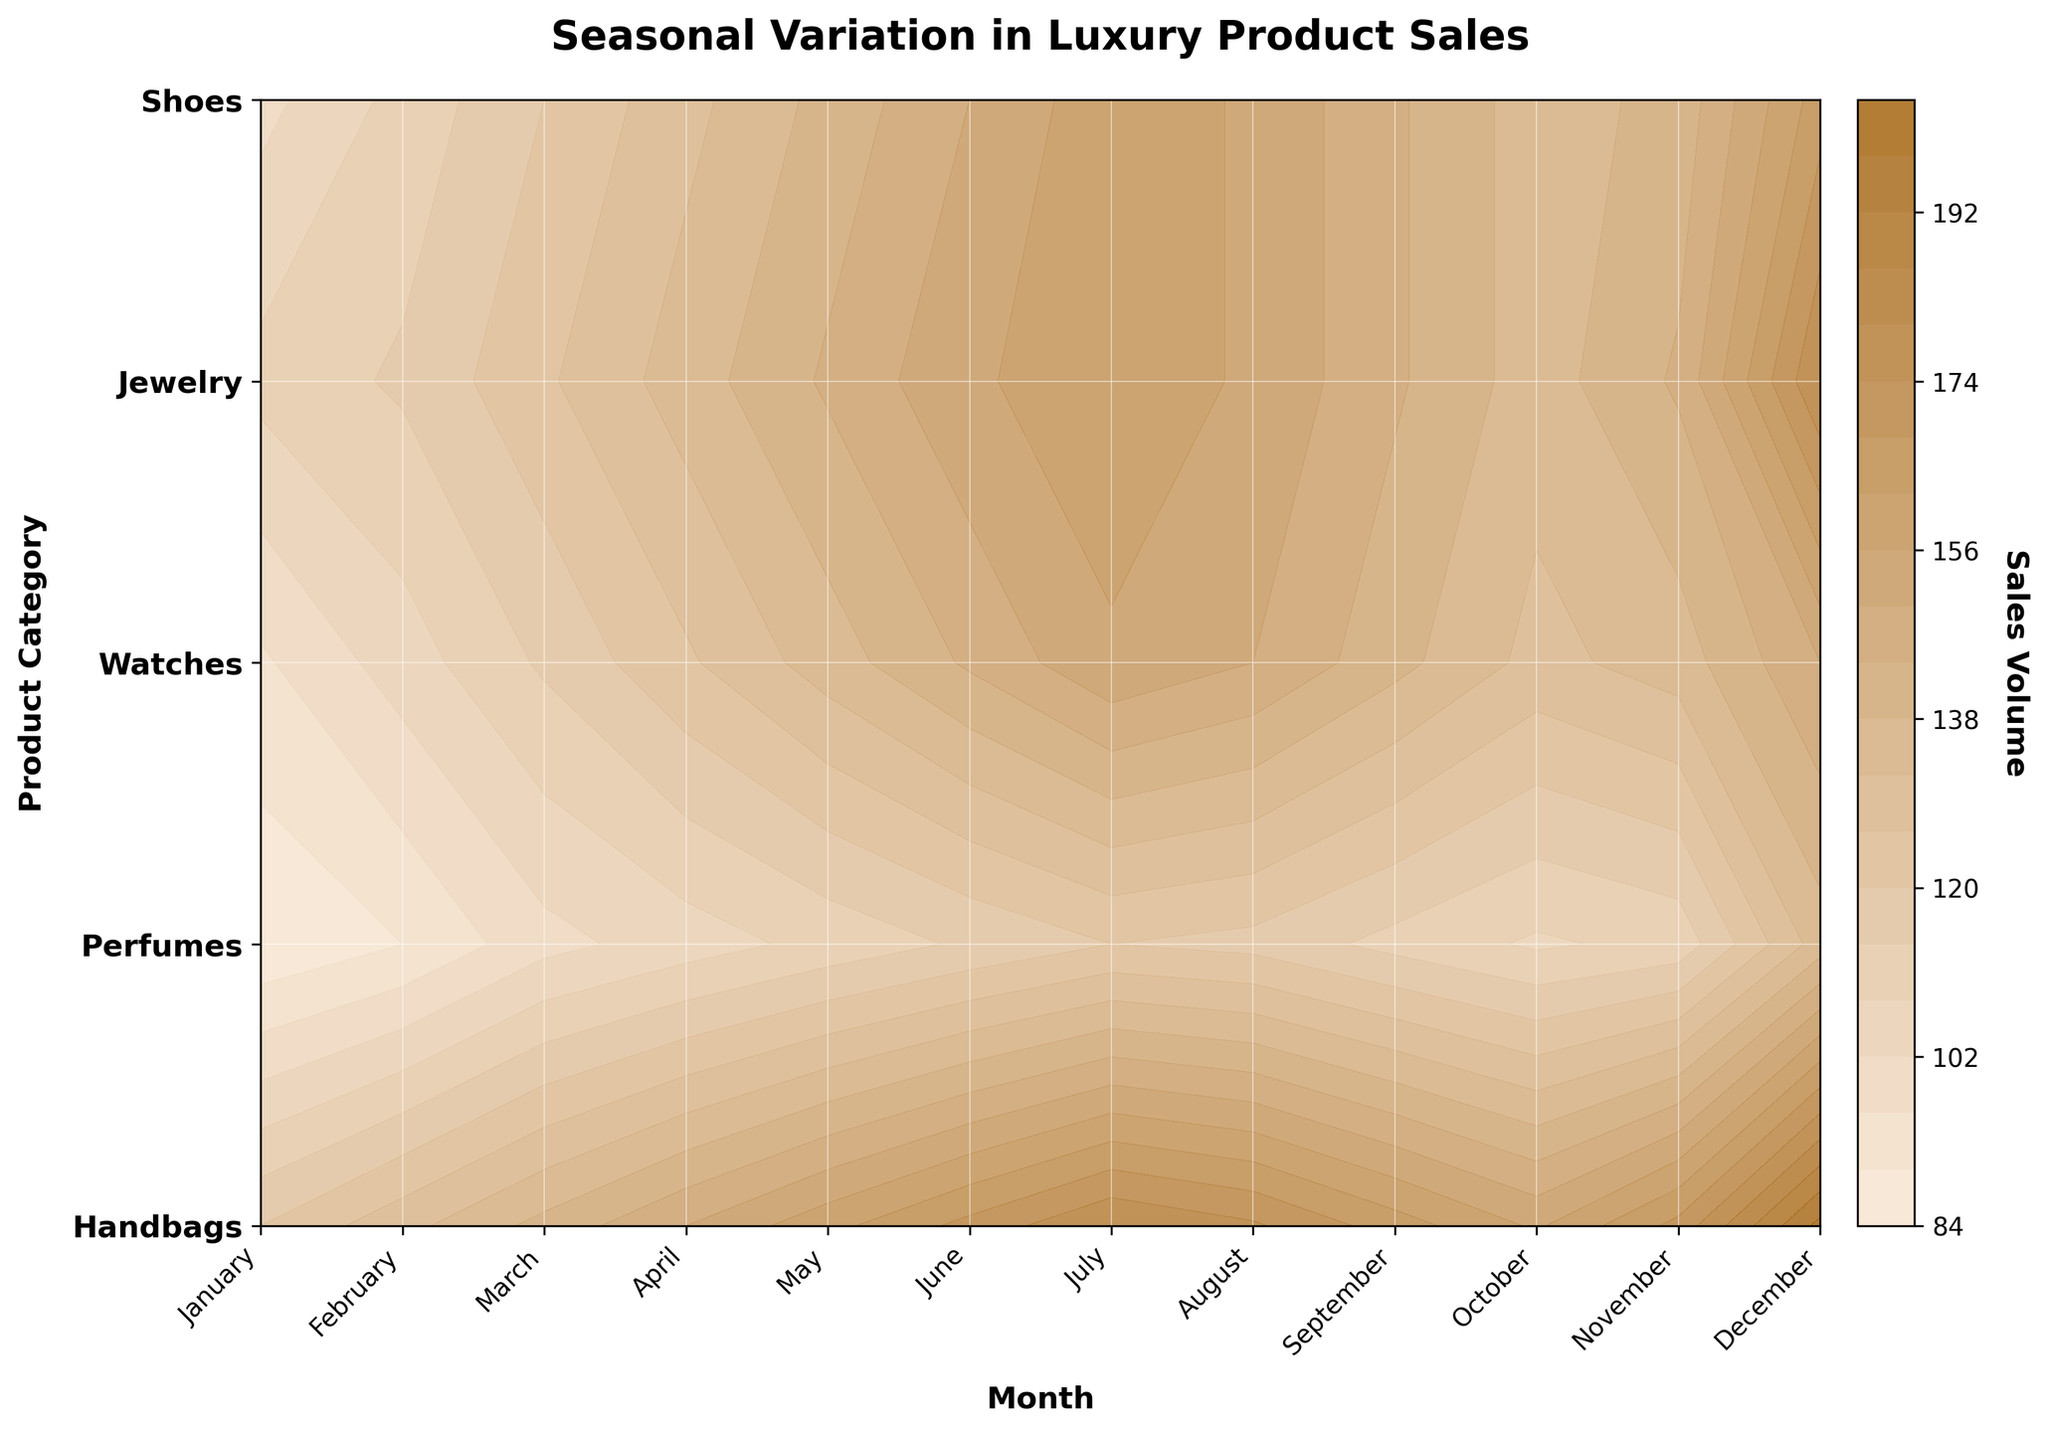What's the title of the plot? The title is displayed at the top of the plot in bold font. The title helps interpret the context of the data being visualized.
Answer: Seasonal Variation in Luxury Product Sales What do the color gradients represent in the plot? The color gradients represent different levels of sales volume, with lighter shades indicating lower sales volumes and darker shades representing higher sales volumes. The gradient transitions smoothly between colors to indicate variations.
Answer: Sales Volume How are the product categories represented on the plot? The product categories are shown on the y-axis of the plot. Each category is labeled and there are corresponding contour lines that indicate the sales volumes for each category over the months.
Answer: On the y-axis Which product category has the highest sales volume in December? To find this, look at the color gradients for December and identify the darkest shade. For December, the darkest shade corresponds to Jewelry.
Answer: Jewelry During which month do Handbags show a significant increase in sales compared to the previous month? Observe the contour changes for Handbags on the plot. The month-to-month data shows a significant increase from October to November. The contours darken considerably.
Answer: November For which month does the plot show the lowest sales volume for Perfumes? Look at the color gradient for Perfumes for each month. The lightest shade for Perfumes occurs in October.
Answer: October Which product category shows a noticeable sales peak in June? Examine the contour lines for June. The darkest shade in June corresponds to Handbags, indicating a peak in sales volume.
Answer: Handbags How does the sales pattern for Watches in August compare to July? Looking at the color gradients, Watches show a slightly lighter shade in August compared to July. This indicates a slight decrease in sales volume.
Answer: Slight decrease Summarize the overall seasonality observed for Shoes. By following the color gradients for Shoes throughout the year, it’s noticeable that sales volumes gradually increase from January to July, slightly decrease in August, and then have another peak in December.
Answer: Increase Jan-July, peak in Dec What differences can be observed in the sales pattern between Handbags and Perfumes across the year? Compare the color gradients for Handbags and Perfumes for each month. Handbags generally show a more steady increase throughout the year with a peak in December, whereas Perfumes show more variability with lower sales in February and October and a peak in December.
Answer: Handbags increase steadily, Perfumes are variable 